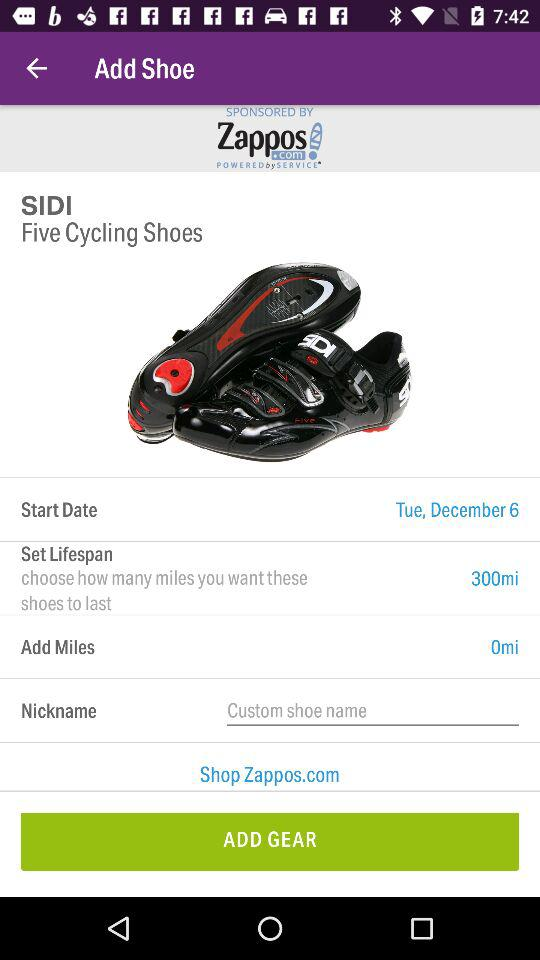What is the start date? The start date is Tuesday, December 6. 